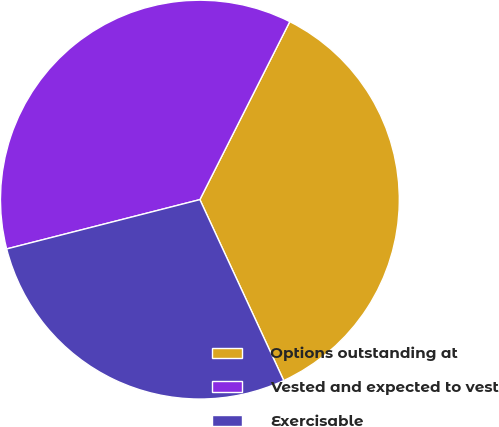Convert chart to OTSL. <chart><loc_0><loc_0><loc_500><loc_500><pie_chart><fcel>Options outstanding at<fcel>Vested and expected to vest<fcel>Exercisable<nl><fcel>35.65%<fcel>36.42%<fcel>27.93%<nl></chart> 